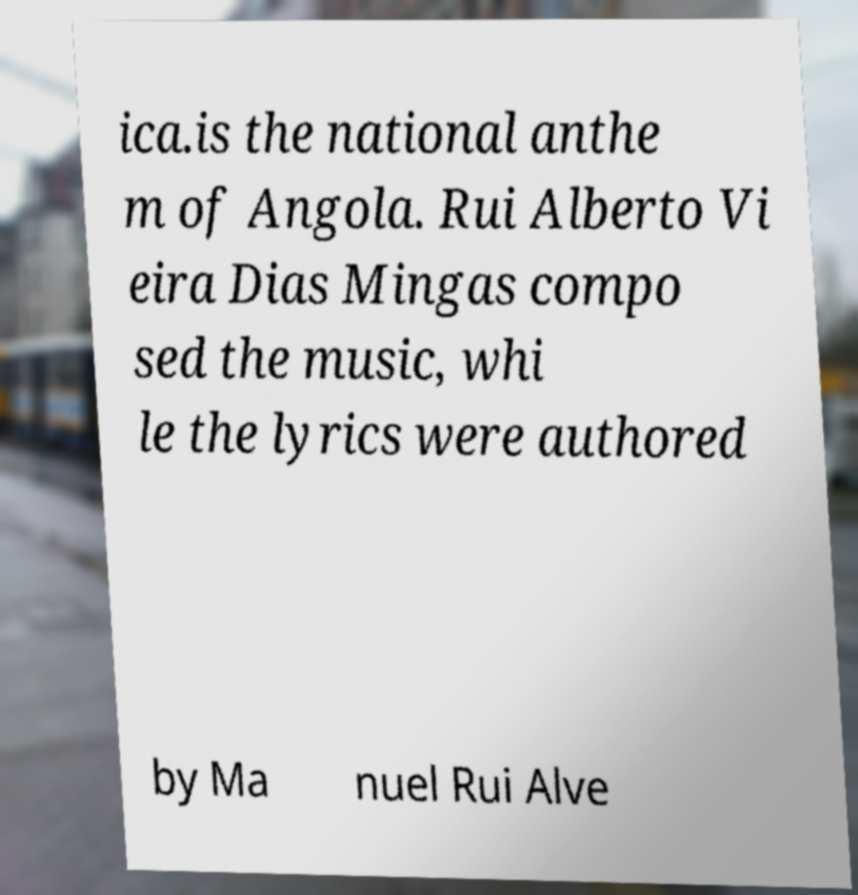Could you extract and type out the text from this image? ica.is the national anthe m of Angola. Rui Alberto Vi eira Dias Mingas compo sed the music, whi le the lyrics were authored by Ma nuel Rui Alve 